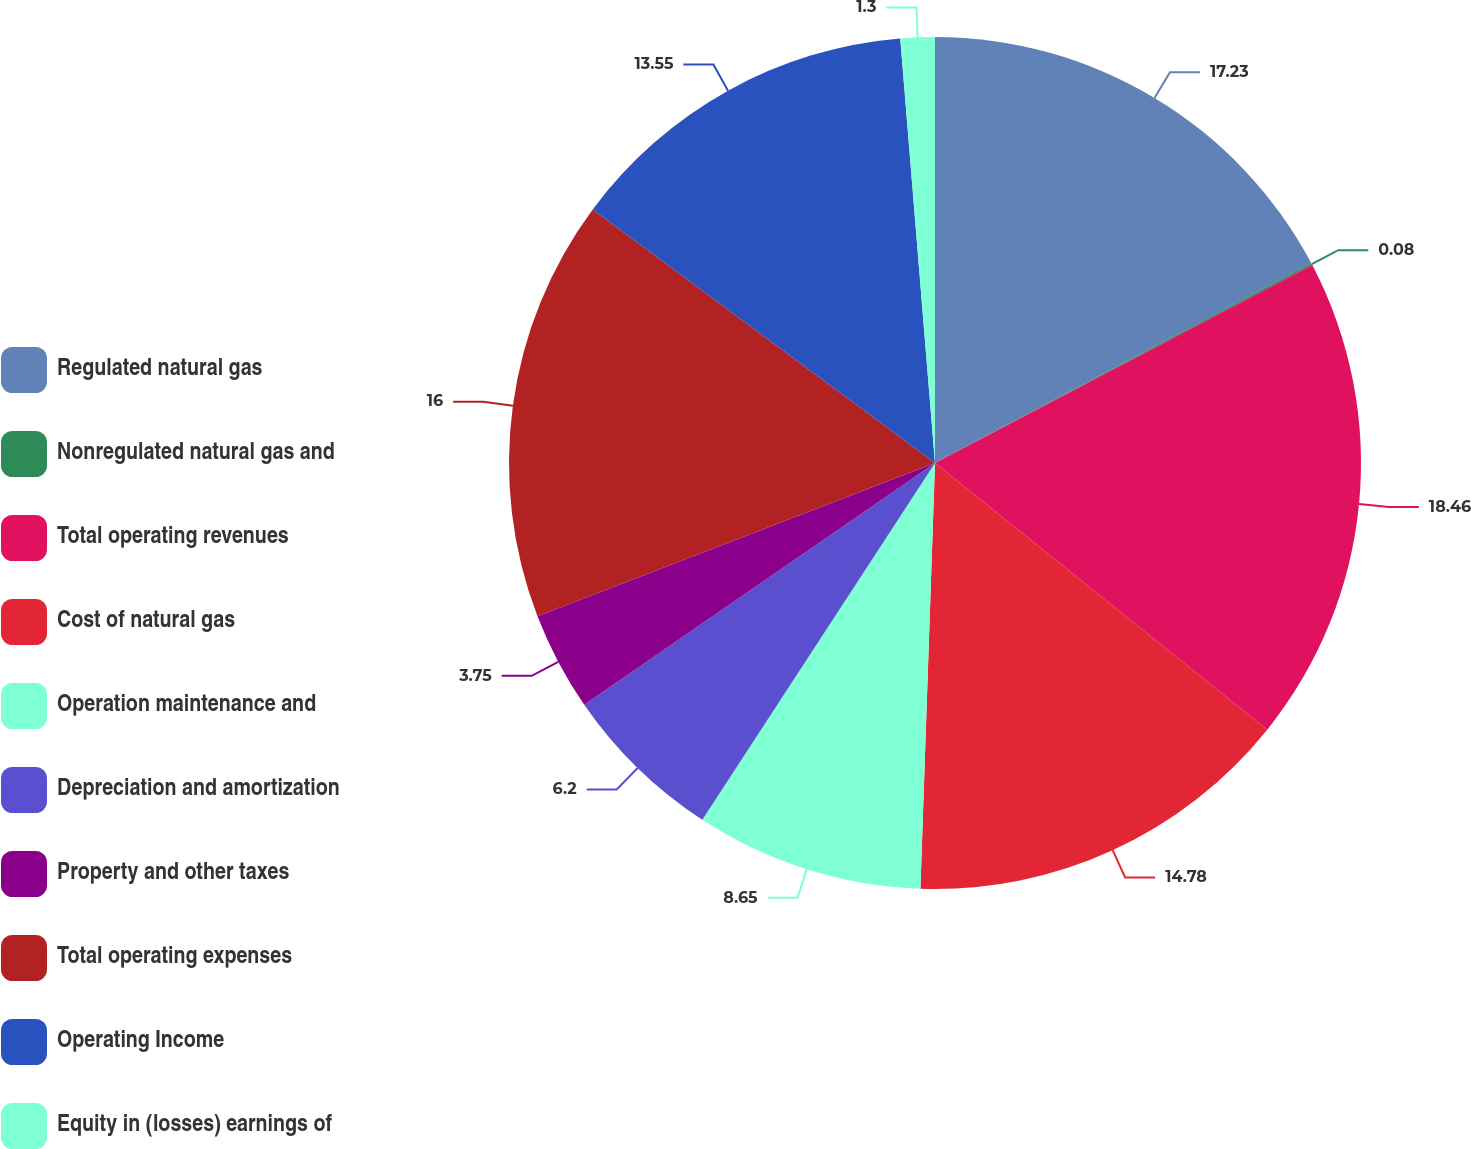<chart> <loc_0><loc_0><loc_500><loc_500><pie_chart><fcel>Regulated natural gas<fcel>Nonregulated natural gas and<fcel>Total operating revenues<fcel>Cost of natural gas<fcel>Operation maintenance and<fcel>Depreciation and amortization<fcel>Property and other taxes<fcel>Total operating expenses<fcel>Operating Income<fcel>Equity in (losses) earnings of<nl><fcel>17.23%<fcel>0.08%<fcel>18.45%<fcel>14.78%<fcel>8.65%<fcel>6.2%<fcel>3.75%<fcel>16.0%<fcel>13.55%<fcel>1.3%<nl></chart> 